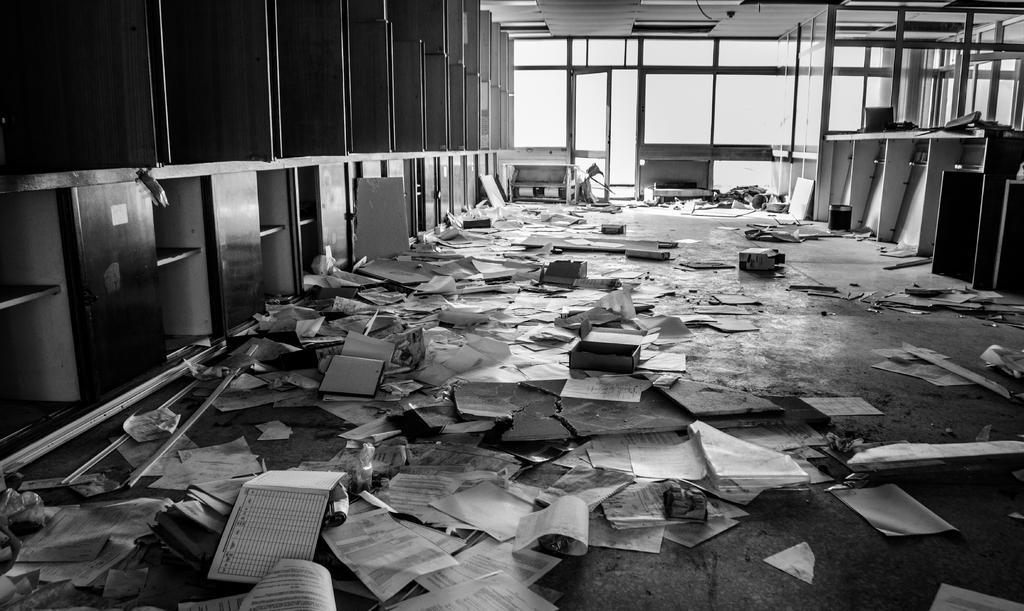Describe this image in one or two sentences. In this image we can see few papers, books and some objects on the floor, there we can see few cupboards, shelves, few glass windows and a door. 